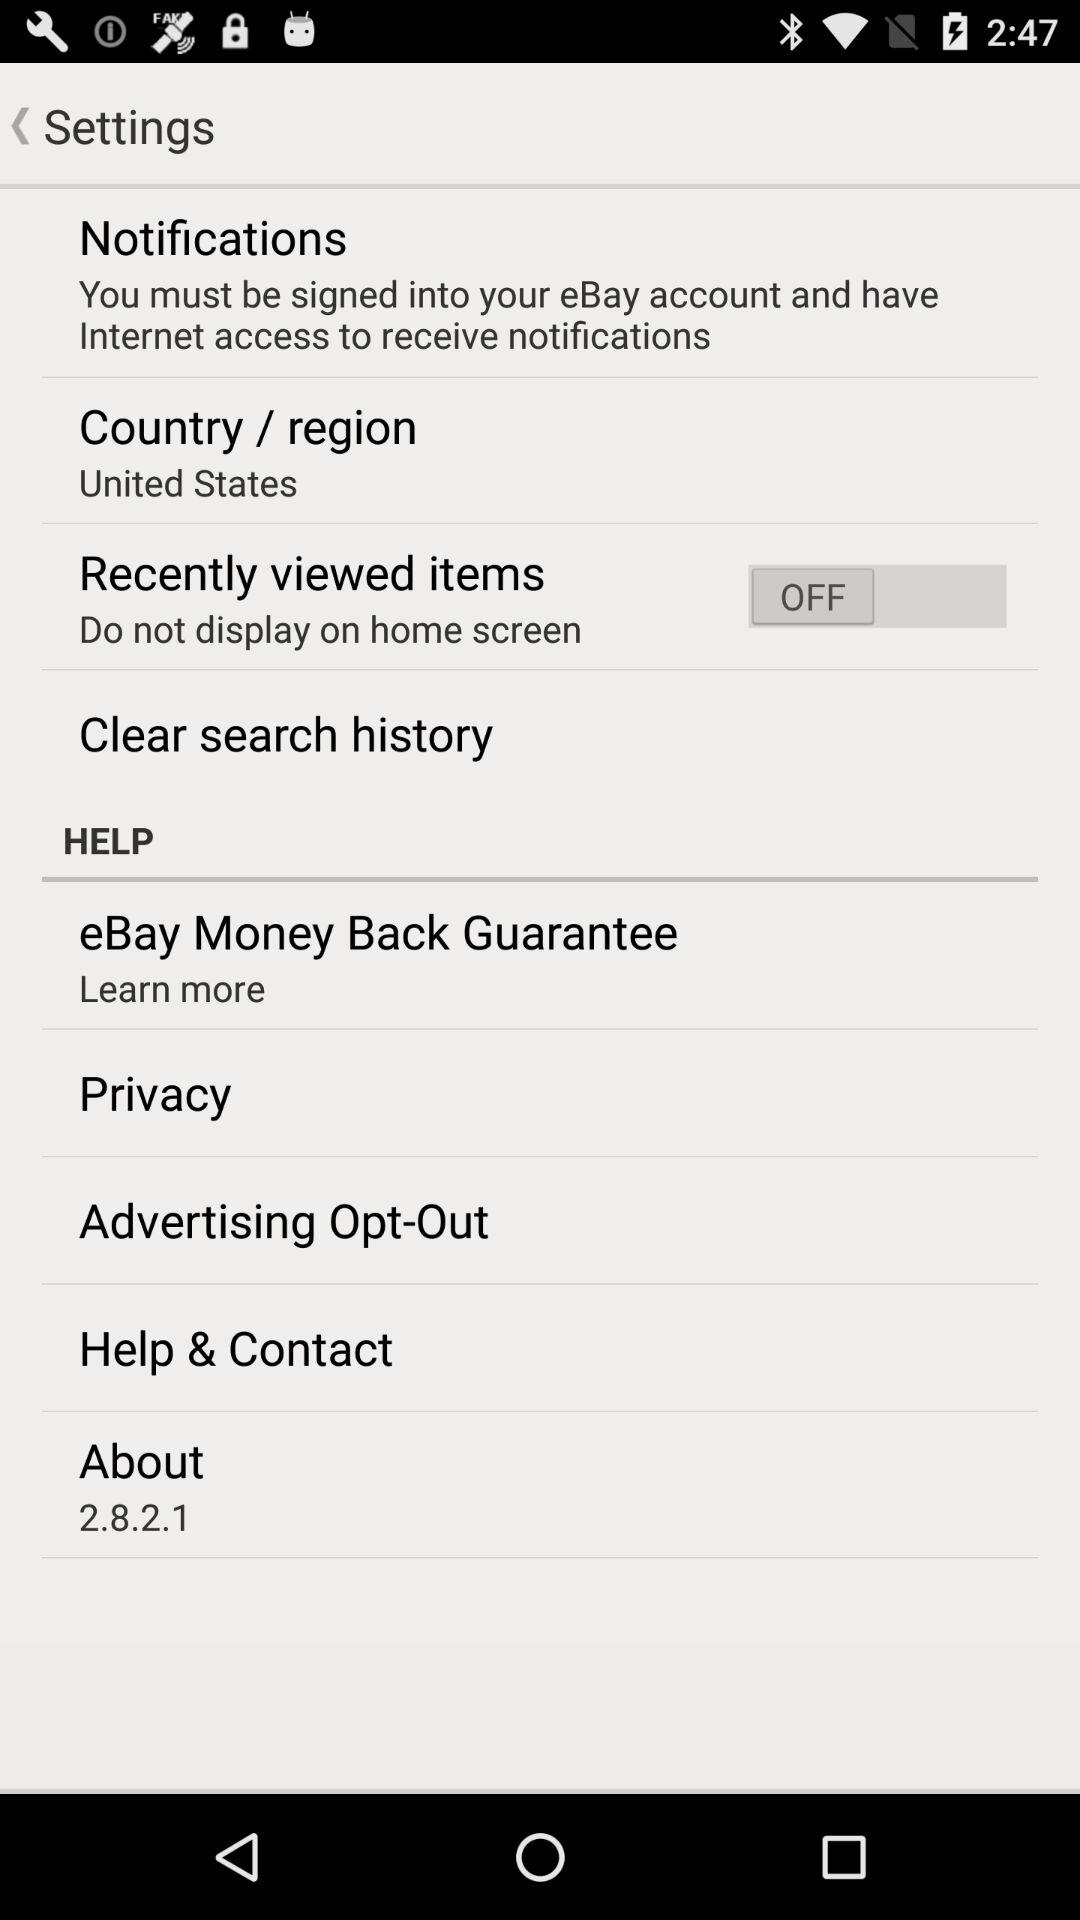What is the status of recently viewed items? The status is off. 